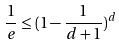<formula> <loc_0><loc_0><loc_500><loc_500>\frac { 1 } { e } \leq ( 1 - \frac { 1 } { d + 1 } ) ^ { d }</formula> 